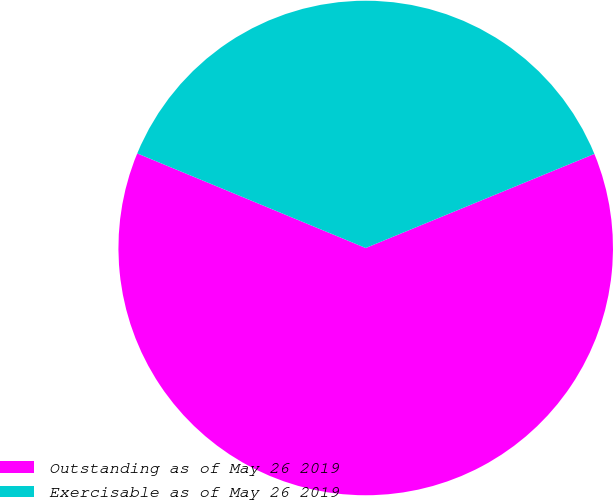Convert chart. <chart><loc_0><loc_0><loc_500><loc_500><pie_chart><fcel>Outstanding as of May 26 2019<fcel>Exercisable as of May 26 2019<nl><fcel>62.46%<fcel>37.54%<nl></chart> 